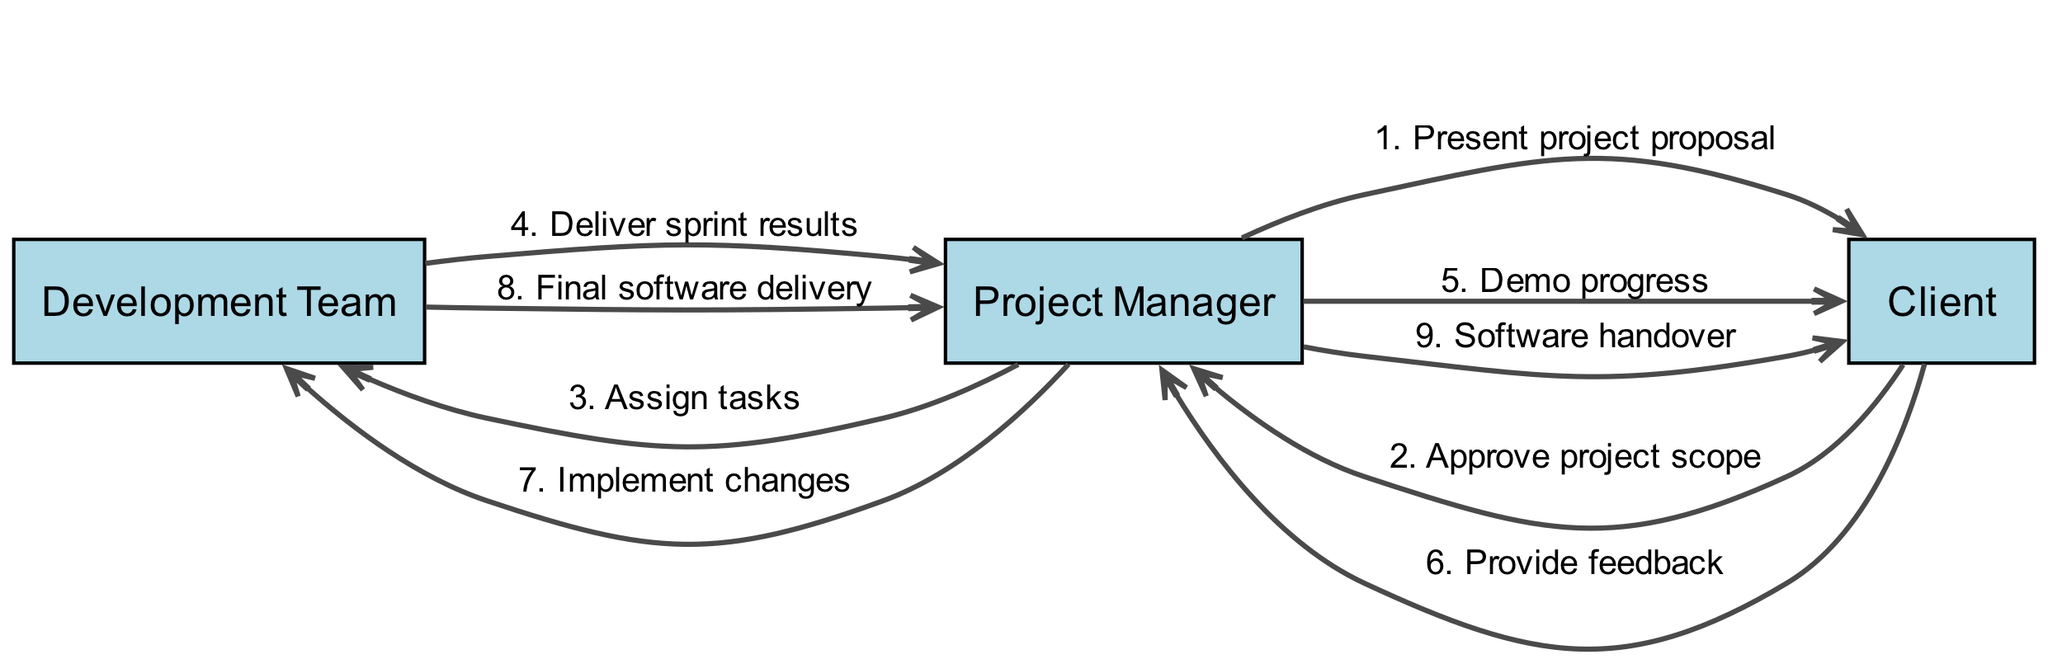What is the first interaction in the diagram? The first interaction listed is from the Project Manager to the Client with the message 'Present project proposal'. This can be found by looking at the first entry in the interactions section.
Answer: Present project proposal How many total interactions are depicted in the diagram? By counting all the interactions listed in the interactions section, there are a total of nine distinct interactions.
Answer: 9 Which actor receives feedback from the Client? The message that indicates feedback is sent from the Client to the Project Manager as noted in the interaction 'Provide feedback'. The Client's feedback is directed toward the Project Manager.
Answer: Project Manager What message is sent after the Development Team delivers sprint results? The interaction right after 'Deliver sprint results' is the Project Manager to the Client with the message 'Demo progress'. This shows the sequential flow of communication following task completion.
Answer: Demo progress Which two actors interact directly to implement changes? The interaction 'Implement changes' involves the Project Manager directing the Development Team to carry out changes. This shows a direct communication pathway between these two roles.
Answer: Project Manager and Development Team How many times does the Client interact with the Project Manager? By reviewing the interactions, the Client interacts with the Project Manager a total of three times: once to approve the project scope, once to provide feedback, and finally to receive the software handover.
Answer: 3 What is the final action shown in the diagram? The last interaction recorded is the Project Manager to the Client with the message 'Software handover', which represents the culmination of the interactions in the sequence diagram.
Answer: Software handover What is the role of the Development Team in relation to the Project Manager? The Development Team's role involves receiving assignments from the Project Manager (Assign tasks) and returning results and final deliveries (Deliver sprint results and Final software delivery). This indicates a supportive and executional relationship.
Answer: Supportive role What do the invisible edges between actors represent? The invisible edges that connect the actors are used for alignment purposes in the diagram. They help to organize the layout without indicating any direct interactions or messages.
Answer: Alignment Which actor initiates the project proposal process? The initiation of the project proposal process is carried out by the Project Manager, who presents the proposal to the Client as the first step in the interaction sequence.
Answer: Project Manager 